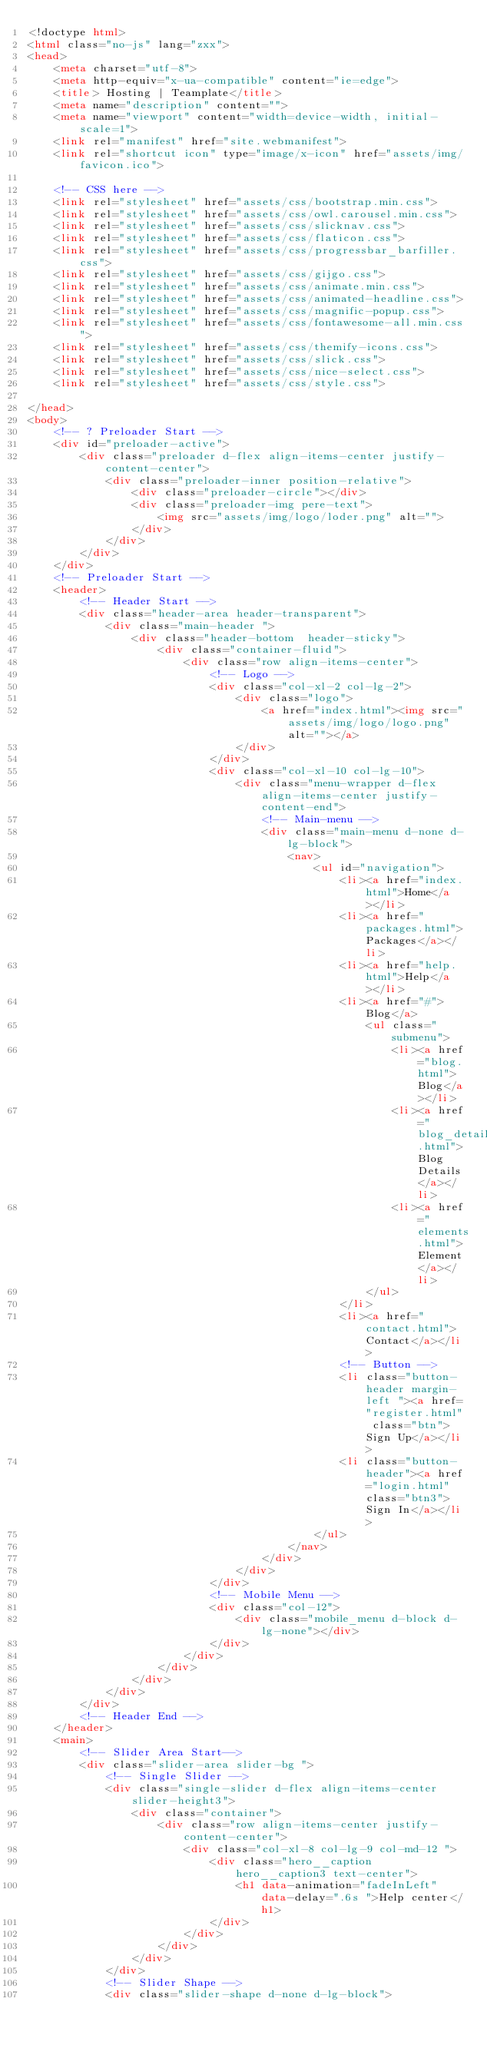Convert code to text. <code><loc_0><loc_0><loc_500><loc_500><_HTML_><!doctype html>
<html class="no-js" lang="zxx">
<head>
    <meta charset="utf-8">
    <meta http-equiv="x-ua-compatible" content="ie=edge">
    <title> Hosting | Teamplate</title>
    <meta name="description" content="">
    <meta name="viewport" content="width=device-width, initial-scale=1">
    <link rel="manifest" href="site.webmanifest">
    <link rel="shortcut icon" type="image/x-icon" href="assets/img/favicon.ico">

    <!-- CSS here -->
    <link rel="stylesheet" href="assets/css/bootstrap.min.css">
    <link rel="stylesheet" href="assets/css/owl.carousel.min.css">
    <link rel="stylesheet" href="assets/css/slicknav.css">
    <link rel="stylesheet" href="assets/css/flaticon.css">
    <link rel="stylesheet" href="assets/css/progressbar_barfiller.css">
    <link rel="stylesheet" href="assets/css/gijgo.css">
    <link rel="stylesheet" href="assets/css/animate.min.css">
    <link rel="stylesheet" href="assets/css/animated-headline.css">
    <link rel="stylesheet" href="assets/css/magnific-popup.css">
    <link rel="stylesheet" href="assets/css/fontawesome-all.min.css">
    <link rel="stylesheet" href="assets/css/themify-icons.css">
    <link rel="stylesheet" href="assets/css/slick.css">
    <link rel="stylesheet" href="assets/css/nice-select.css">
    <link rel="stylesheet" href="assets/css/style.css">
    
</head>
<body>
    <!-- ? Preloader Start -->
    <div id="preloader-active">
        <div class="preloader d-flex align-items-center justify-content-center">
            <div class="preloader-inner position-relative">
                <div class="preloader-circle"></div>
                <div class="preloader-img pere-text">
                    <img src="assets/img/logo/loder.png" alt="">
                </div>
            </div>
        </div>
    </div>
    <!-- Preloader Start -->
    <header>
        <!-- Header Start -->
        <div class="header-area header-transparent">
            <div class="main-header ">
                <div class="header-bottom  header-sticky">
                    <div class="container-fluid">
                        <div class="row align-items-center">
                            <!-- Logo -->
                            <div class="col-xl-2 col-lg-2">
                                <div class="logo">
                                    <a href="index.html"><img src="assets/img/logo/logo.png" alt=""></a>
                                </div>
                            </div>
                            <div class="col-xl-10 col-lg-10">
                                <div class="menu-wrapper d-flex align-items-center justify-content-end">
                                    <!-- Main-menu -->
                                    <div class="main-menu d-none d-lg-block">
                                        <nav>
                                            <ul id="navigation">                                                                                          
                                                <li><a href="index.html">Home</a></li>
                                                <li><a href="packages.html">Packages</a></li>
                                                <li><a href="help.html">Help</a></li>
                                                <li><a href="#">Blog</a>
                                                    <ul class="submenu">
                                                        <li><a href="blog.html">Blog</a></li>
                                                        <li><a href="blog_details.html">Blog Details</a></li>
                                                        <li><a href="elements.html">Element</a></li>
                                                    </ul>
                                                </li>
                                                <li><a href="contact.html">Contact</a></li>
                                                <!-- Button -->
                                                <li class="button-header margin-left "><a href="register.html" class="btn">Sign Up</a></li>
                                                <li class="button-header"><a href="login.html" class="btn3">Sign In</a></li>
                                            </ul>
                                        </nav>
                                    </div>
                                </div>
                            </div> 
                            <!-- Mobile Menu -->
                            <div class="col-12">
                                <div class="mobile_menu d-block d-lg-none"></div>
                            </div>
                        </div>
                    </div>
                </div>
            </div>
        </div>
        <!-- Header End -->
    </header>
    <main>
        <!-- Slider Area Start-->
        <div class="slider-area slider-bg ">
            <!-- Single Slider -->
            <div class="single-slider d-flex align-items-center slider-height3">
                <div class="container">
                    <div class="row align-items-center justify-content-center">
                        <div class="col-xl-8 col-lg-9 col-md-12 ">
                            <div class="hero__caption hero__caption3 text-center">
                                <h1 data-animation="fadeInLeft" data-delay=".6s ">Help center</h1>
                            </div>
                        </div>
                    </div>
                </div>
            </div>    
            <!-- Slider Shape -->
            <div class="slider-shape d-none d-lg-block"></code> 